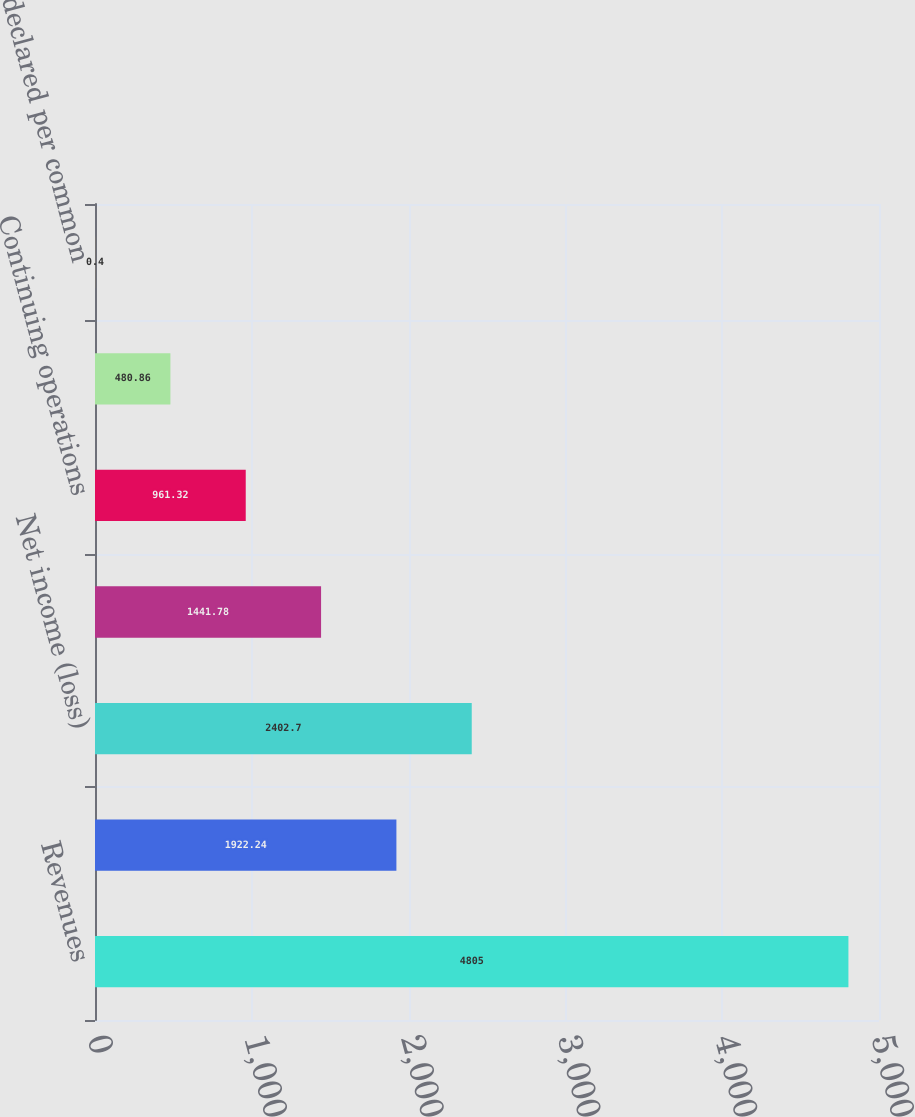Convert chart to OTSL. <chart><loc_0><loc_0><loc_500><loc_500><bar_chart><fcel>Revenues<fcel>Income (loss) from continuing<fcel>Net income (loss)<fcel>Net income (loss) attributable<fcel>Continuing operations<fcel>Discontinued operations<fcel>Dividends declared per common<nl><fcel>4805<fcel>1922.24<fcel>2402.7<fcel>1441.78<fcel>961.32<fcel>480.86<fcel>0.4<nl></chart> 